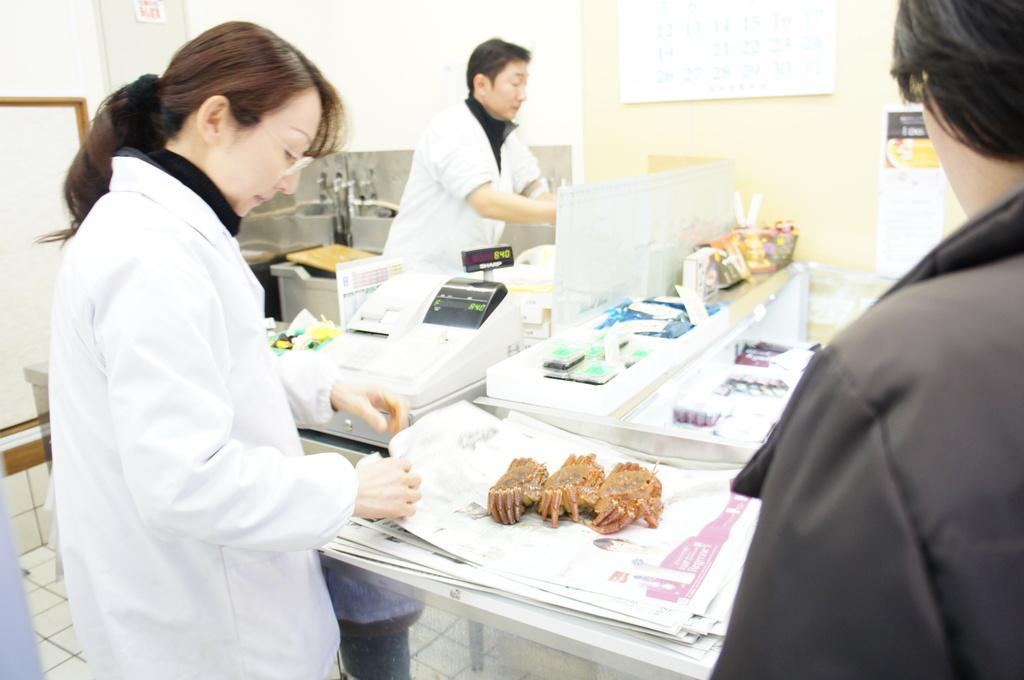Can you describe this image briefly? In this image we can see the persons standing on the floor and there are tables, on the table there are bowls, meat, papers, tap, weighing machine and a few objects on it. And there are banners attached to the wall. 